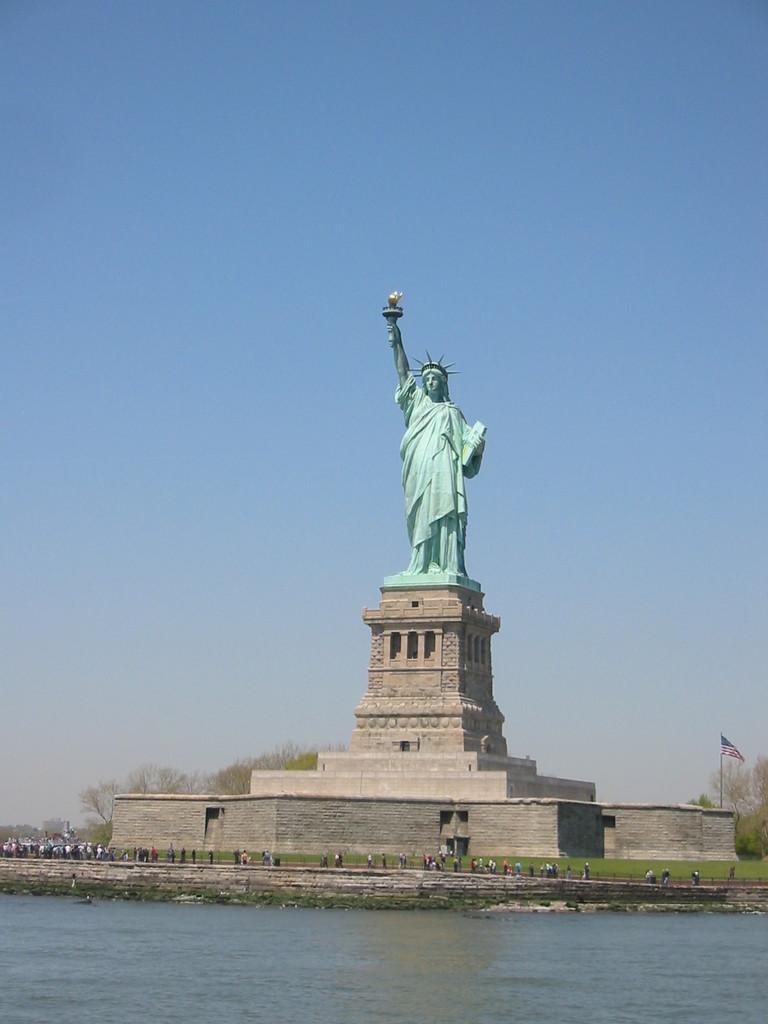Please provide a concise description of this image. In this image there is a statue of liberty and in front of the statue there is a river and at the center people are standing on surface of the grass. At the back side there are trees and sky. 